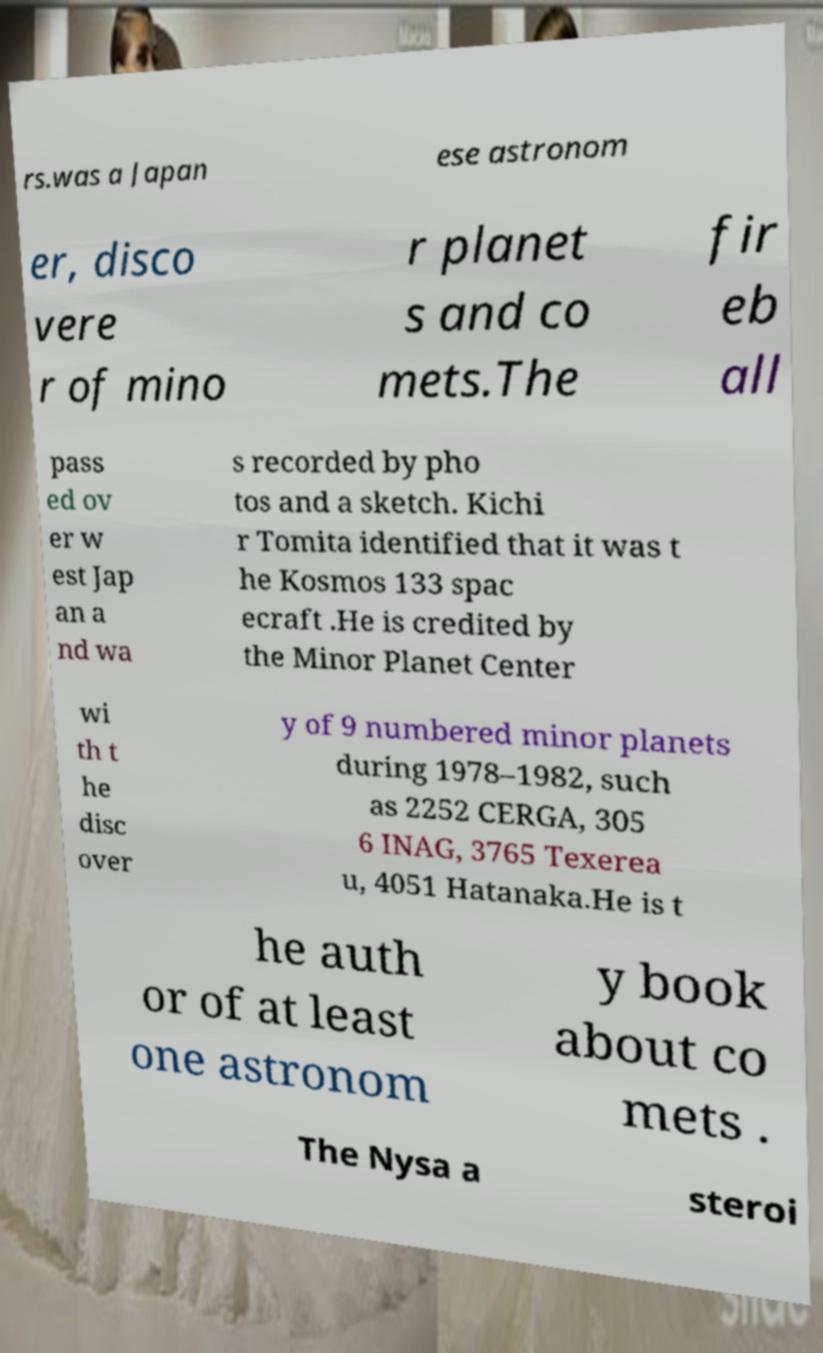What messages or text are displayed in this image? I need them in a readable, typed format. rs.was a Japan ese astronom er, disco vere r of mino r planet s and co mets.The fir eb all pass ed ov er w est Jap an a nd wa s recorded by pho tos and a sketch. Kichi r Tomita identified that it was t he Kosmos 133 spac ecraft .He is credited by the Minor Planet Center wi th t he disc over y of 9 numbered minor planets during 1978–1982, such as 2252 CERGA, 305 6 INAG, 3765 Texerea u, 4051 Hatanaka.He is t he auth or of at least one astronom y book about co mets . The Nysa a steroi 